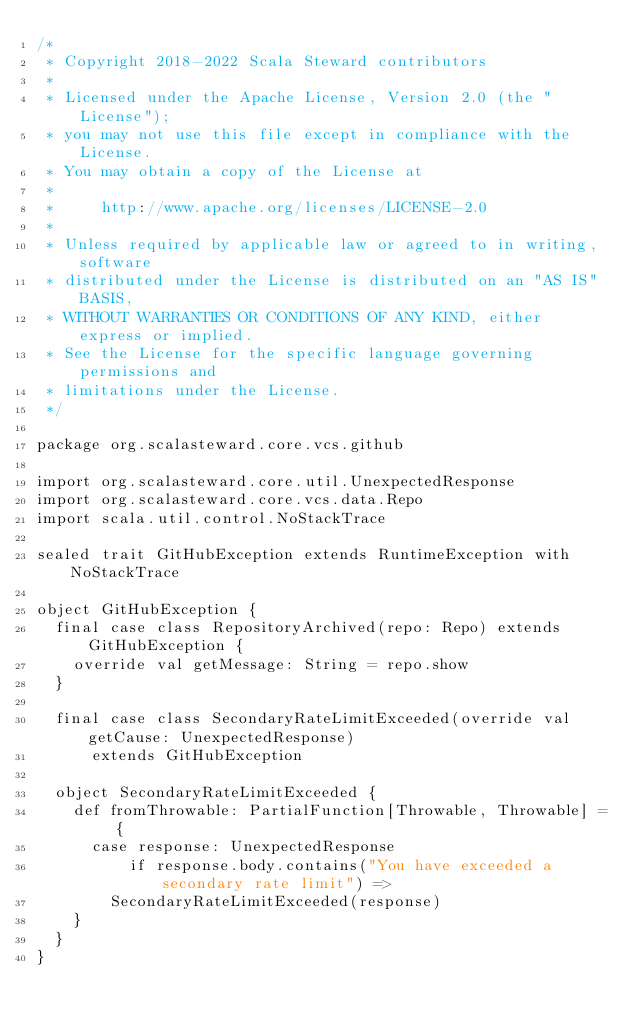Convert code to text. <code><loc_0><loc_0><loc_500><loc_500><_Scala_>/*
 * Copyright 2018-2022 Scala Steward contributors
 *
 * Licensed under the Apache License, Version 2.0 (the "License");
 * you may not use this file except in compliance with the License.
 * You may obtain a copy of the License at
 *
 *     http://www.apache.org/licenses/LICENSE-2.0
 *
 * Unless required by applicable law or agreed to in writing, software
 * distributed under the License is distributed on an "AS IS" BASIS,
 * WITHOUT WARRANTIES OR CONDITIONS OF ANY KIND, either express or implied.
 * See the License for the specific language governing permissions and
 * limitations under the License.
 */

package org.scalasteward.core.vcs.github

import org.scalasteward.core.util.UnexpectedResponse
import org.scalasteward.core.vcs.data.Repo
import scala.util.control.NoStackTrace

sealed trait GitHubException extends RuntimeException with NoStackTrace

object GitHubException {
  final case class RepositoryArchived(repo: Repo) extends GitHubException {
    override val getMessage: String = repo.show
  }

  final case class SecondaryRateLimitExceeded(override val getCause: UnexpectedResponse)
      extends GitHubException

  object SecondaryRateLimitExceeded {
    def fromThrowable: PartialFunction[Throwable, Throwable] = {
      case response: UnexpectedResponse
          if response.body.contains("You have exceeded a secondary rate limit") =>
        SecondaryRateLimitExceeded(response)
    }
  }
}
</code> 